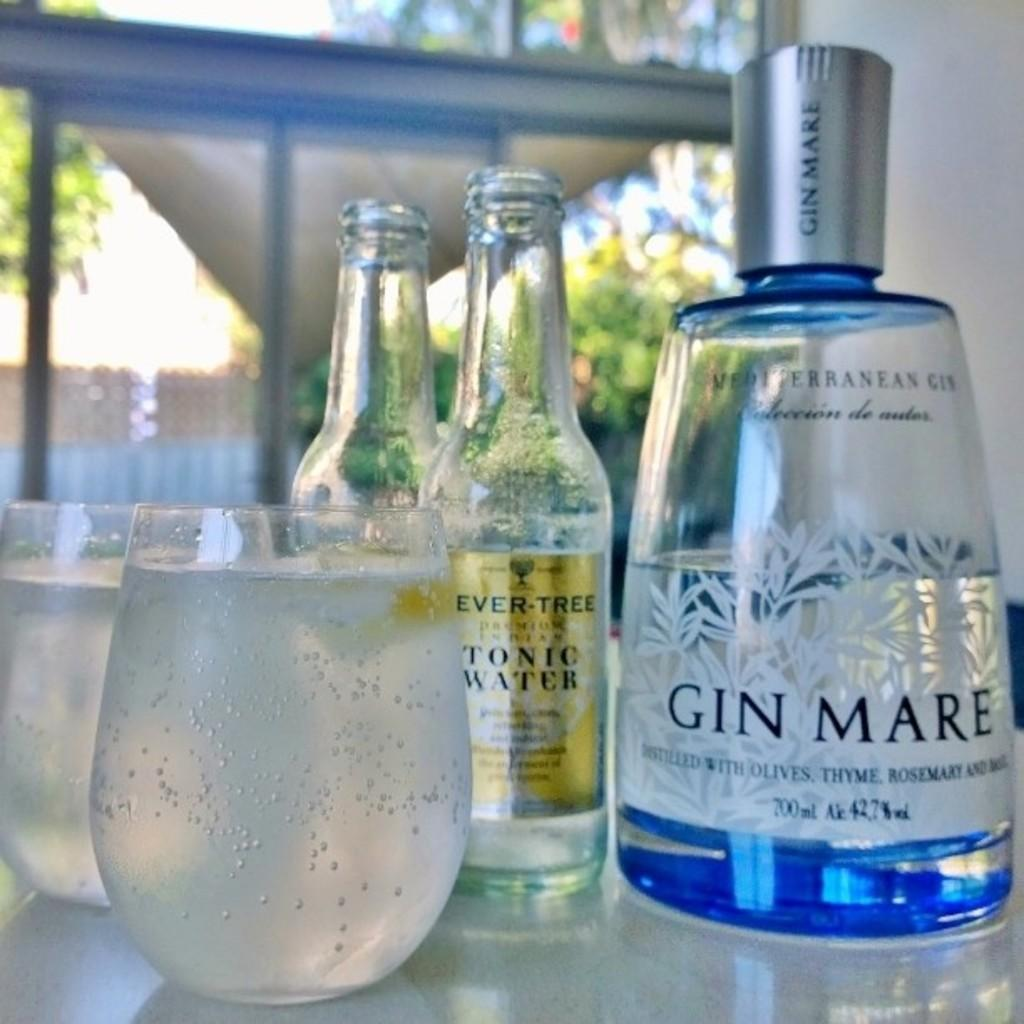Provide a one-sentence caption for the provided image. Bottles of Gin Mare and Tonic Water are poured into glasses on a table. 